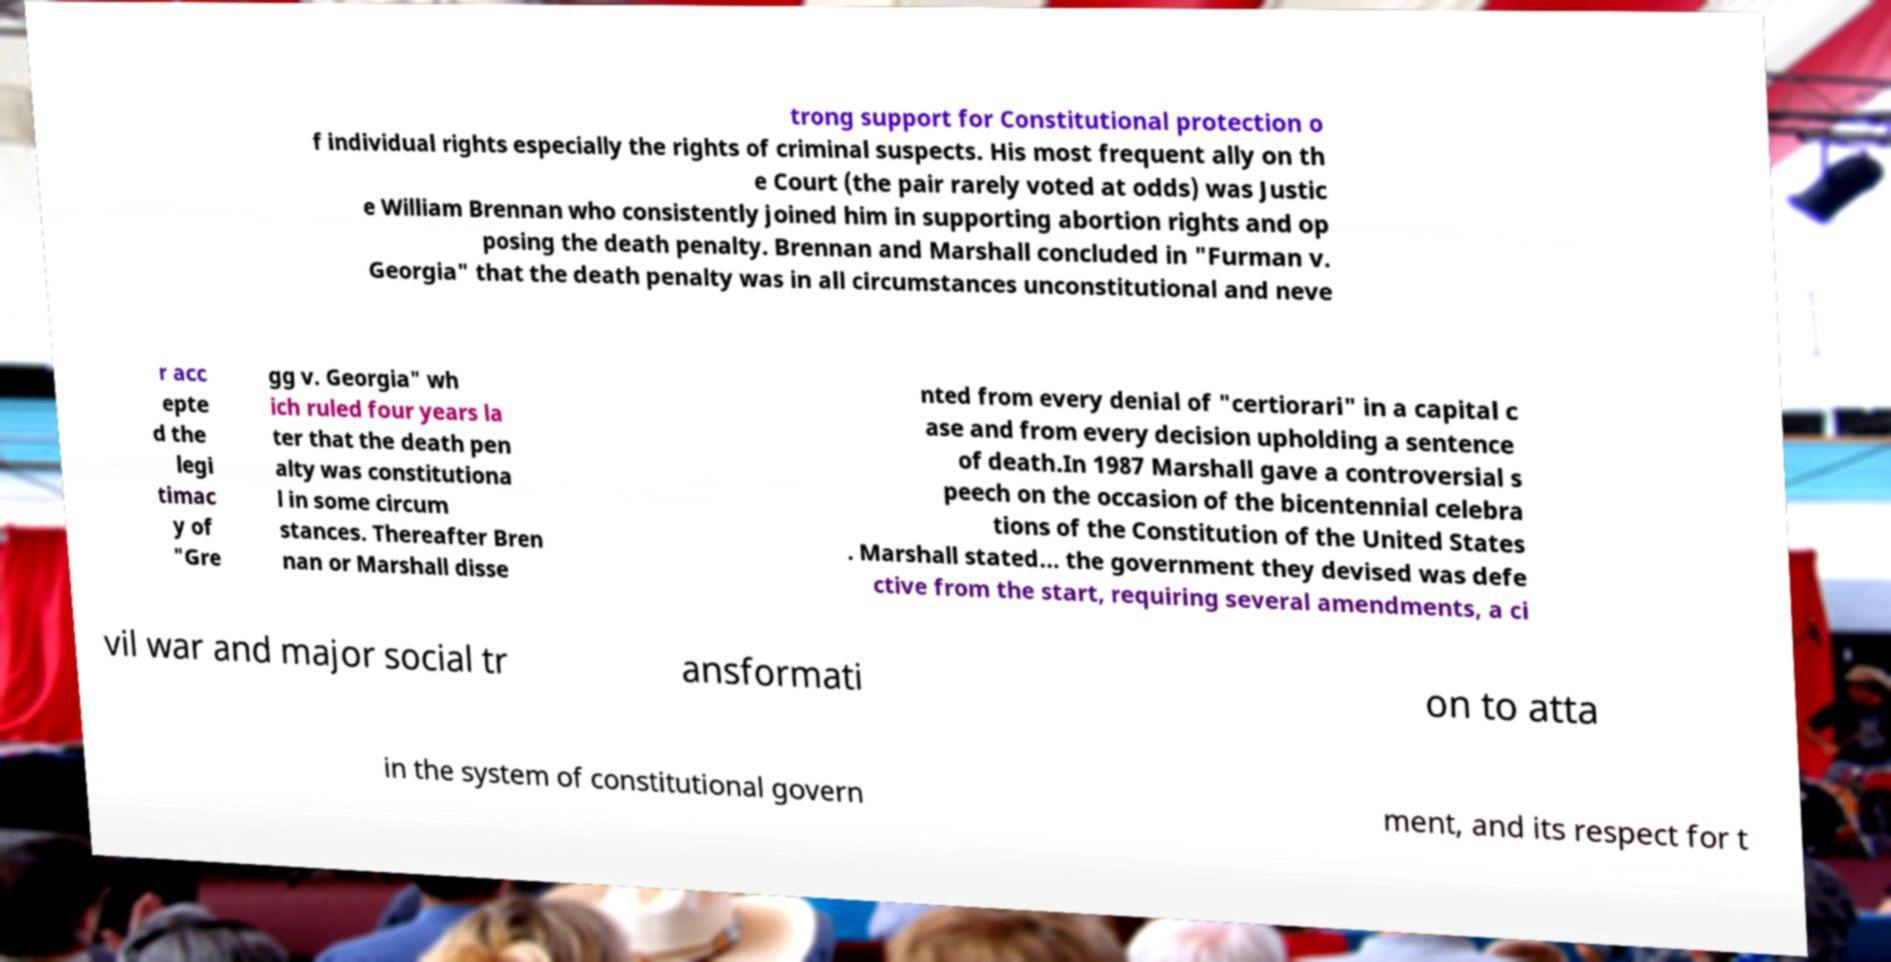I need the written content from this picture converted into text. Can you do that? trong support for Constitutional protection o f individual rights especially the rights of criminal suspects. His most frequent ally on th e Court (the pair rarely voted at odds) was Justic e William Brennan who consistently joined him in supporting abortion rights and op posing the death penalty. Brennan and Marshall concluded in "Furman v. Georgia" that the death penalty was in all circumstances unconstitutional and neve r acc epte d the legi timac y of "Gre gg v. Georgia" wh ich ruled four years la ter that the death pen alty was constitutiona l in some circum stances. Thereafter Bren nan or Marshall disse nted from every denial of "certiorari" in a capital c ase and from every decision upholding a sentence of death.In 1987 Marshall gave a controversial s peech on the occasion of the bicentennial celebra tions of the Constitution of the United States . Marshall stated... the government they devised was defe ctive from the start, requiring several amendments, a ci vil war and major social tr ansformati on to atta in the system of constitutional govern ment, and its respect for t 